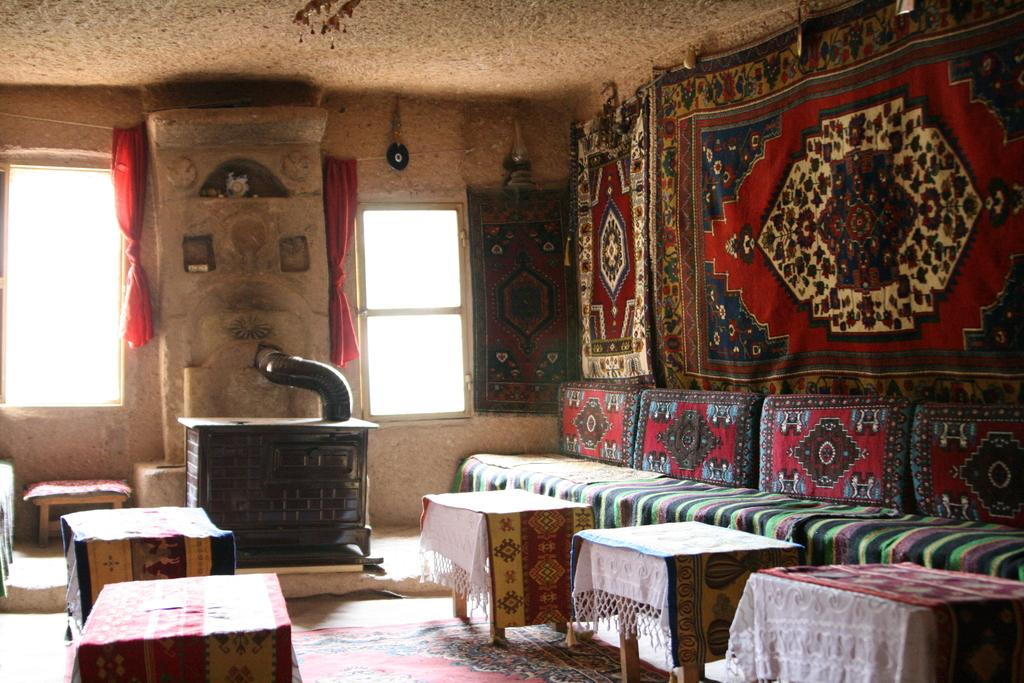What type of floor covering is visible in the image? There are carpets in the image. What type of furniture is present in the image? There is a sofa, tables, and a stool in the image. What type of seating is available in the image? There are pillows and a sofa in the image. What architectural features can be seen in the image? There are windows, curtains, and a wall in the image. Is there a veil draped over the sofa in the image? No, there is no veil present in the image. What type of party is being held in the image? There is no party depicted in the image; it shows a room with furniture and decor. 